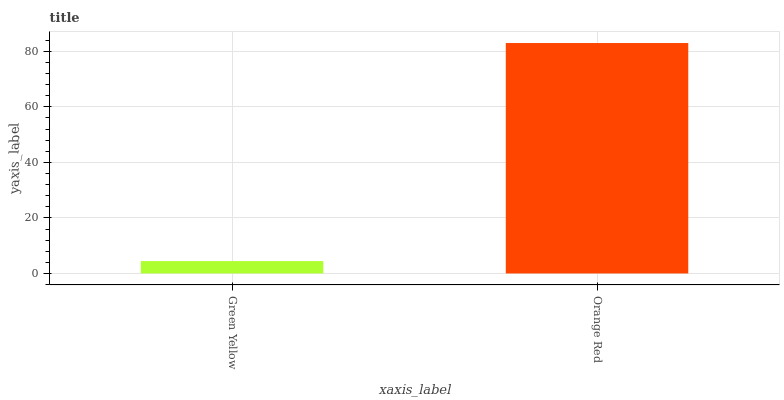Is Green Yellow the minimum?
Answer yes or no. Yes. Is Orange Red the maximum?
Answer yes or no. Yes. Is Orange Red the minimum?
Answer yes or no. No. Is Orange Red greater than Green Yellow?
Answer yes or no. Yes. Is Green Yellow less than Orange Red?
Answer yes or no. Yes. Is Green Yellow greater than Orange Red?
Answer yes or no. No. Is Orange Red less than Green Yellow?
Answer yes or no. No. Is Orange Red the high median?
Answer yes or no. Yes. Is Green Yellow the low median?
Answer yes or no. Yes. Is Green Yellow the high median?
Answer yes or no. No. Is Orange Red the low median?
Answer yes or no. No. 